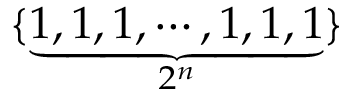Convert formula to latex. <formula><loc_0><loc_0><loc_500><loc_500>\{ \underbrace { 1 , 1 , 1 , \cdots , 1 , 1 , 1 } _ { 2 ^ { n } } \}</formula> 